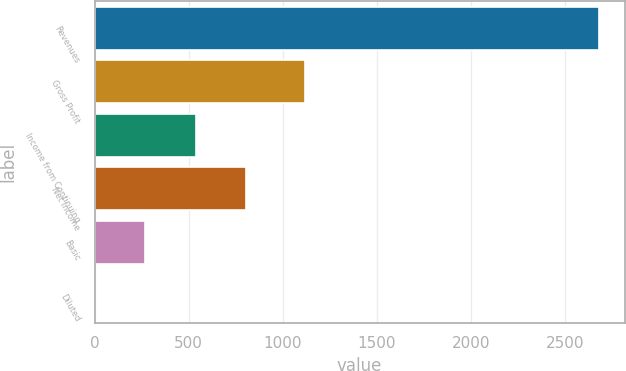Convert chart. <chart><loc_0><loc_0><loc_500><loc_500><bar_chart><fcel>Revenues<fcel>Gross Profit<fcel>Income from Continuing<fcel>Net Income<fcel>Basic<fcel>Diluted<nl><fcel>2682.6<fcel>1116.3<fcel>537.03<fcel>805.23<fcel>268.83<fcel>0.63<nl></chart> 